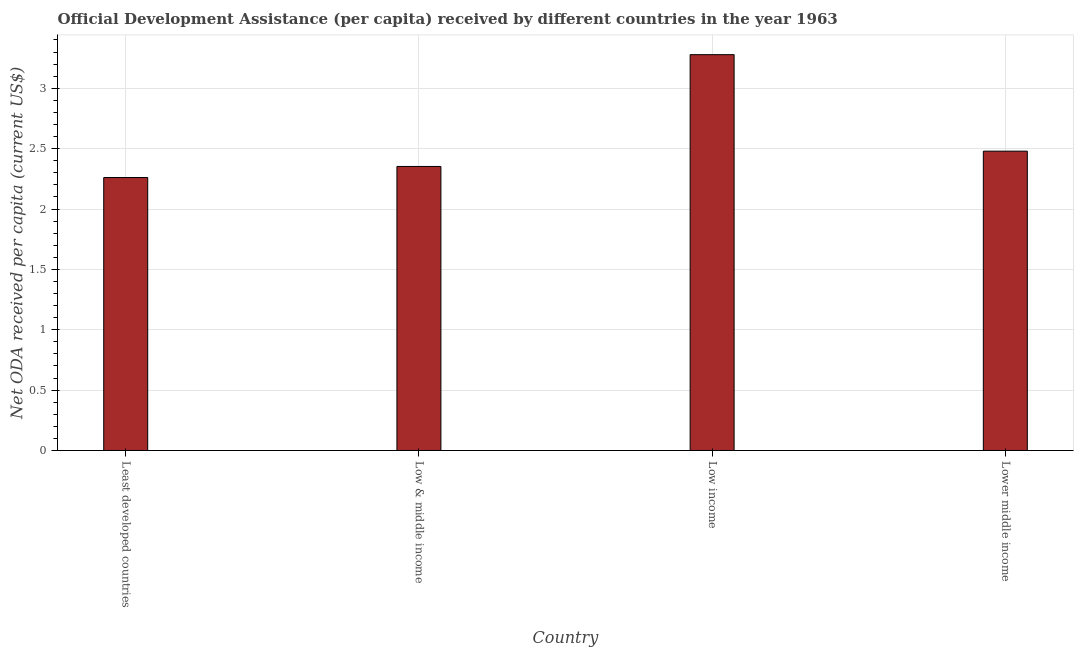Does the graph contain any zero values?
Your answer should be compact. No. What is the title of the graph?
Give a very brief answer. Official Development Assistance (per capita) received by different countries in the year 1963. What is the label or title of the Y-axis?
Make the answer very short. Net ODA received per capita (current US$). What is the net oda received per capita in Least developed countries?
Your answer should be very brief. 2.26. Across all countries, what is the maximum net oda received per capita?
Give a very brief answer. 3.28. Across all countries, what is the minimum net oda received per capita?
Make the answer very short. 2.26. In which country was the net oda received per capita maximum?
Ensure brevity in your answer.  Low income. In which country was the net oda received per capita minimum?
Your answer should be very brief. Least developed countries. What is the sum of the net oda received per capita?
Make the answer very short. 10.37. What is the difference between the net oda received per capita in Least developed countries and Low income?
Keep it short and to the point. -1.02. What is the average net oda received per capita per country?
Ensure brevity in your answer.  2.59. What is the median net oda received per capita?
Give a very brief answer. 2.42. In how many countries, is the net oda received per capita greater than 2.7 US$?
Ensure brevity in your answer.  1. What is the ratio of the net oda received per capita in Low income to that in Lower middle income?
Ensure brevity in your answer.  1.32. What is the difference between the highest and the second highest net oda received per capita?
Your answer should be very brief. 0.8. Is the sum of the net oda received per capita in Least developed countries and Lower middle income greater than the maximum net oda received per capita across all countries?
Your response must be concise. Yes. What is the difference between the highest and the lowest net oda received per capita?
Provide a short and direct response. 1.02. In how many countries, is the net oda received per capita greater than the average net oda received per capita taken over all countries?
Ensure brevity in your answer.  1. How many countries are there in the graph?
Provide a short and direct response. 4. What is the difference between two consecutive major ticks on the Y-axis?
Keep it short and to the point. 0.5. What is the Net ODA received per capita (current US$) in Least developed countries?
Your answer should be compact. 2.26. What is the Net ODA received per capita (current US$) of Low & middle income?
Give a very brief answer. 2.35. What is the Net ODA received per capita (current US$) in Low income?
Provide a short and direct response. 3.28. What is the Net ODA received per capita (current US$) in Lower middle income?
Ensure brevity in your answer.  2.48. What is the difference between the Net ODA received per capita (current US$) in Least developed countries and Low & middle income?
Offer a very short reply. -0.09. What is the difference between the Net ODA received per capita (current US$) in Least developed countries and Low income?
Ensure brevity in your answer.  -1.02. What is the difference between the Net ODA received per capita (current US$) in Least developed countries and Lower middle income?
Provide a short and direct response. -0.22. What is the difference between the Net ODA received per capita (current US$) in Low & middle income and Low income?
Your answer should be very brief. -0.93. What is the difference between the Net ODA received per capita (current US$) in Low & middle income and Lower middle income?
Provide a succinct answer. -0.13. What is the difference between the Net ODA received per capita (current US$) in Low income and Lower middle income?
Provide a succinct answer. 0.8. What is the ratio of the Net ODA received per capita (current US$) in Least developed countries to that in Low income?
Offer a terse response. 0.69. What is the ratio of the Net ODA received per capita (current US$) in Least developed countries to that in Lower middle income?
Offer a very short reply. 0.91. What is the ratio of the Net ODA received per capita (current US$) in Low & middle income to that in Low income?
Offer a terse response. 0.72. What is the ratio of the Net ODA received per capita (current US$) in Low & middle income to that in Lower middle income?
Offer a terse response. 0.95. What is the ratio of the Net ODA received per capita (current US$) in Low income to that in Lower middle income?
Your answer should be compact. 1.32. 